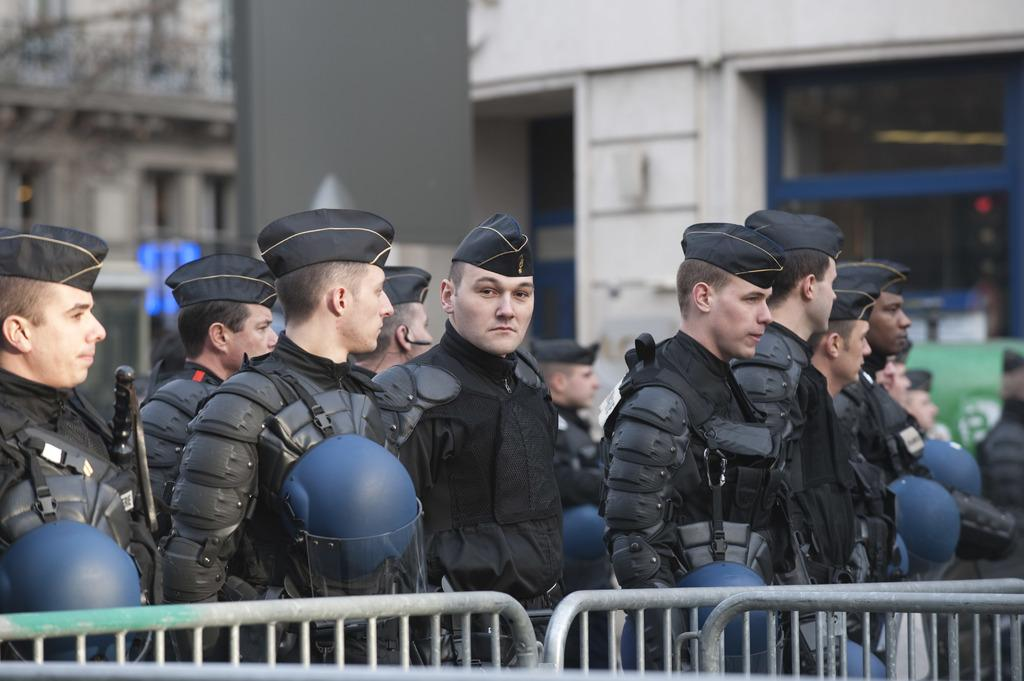What can be seen in the foreground of the image? There are railings in the foreground of the image. What is happening with the group of people in the image? There is a group of people with similar costumes in the image. How is the background of the people depicted in the image? The background of the people is blurred. What type of toothpaste is being used by the people in the image? There is no toothpaste present in the image. What kind of bears can be seen interacting with the people in the image? There are no bears present in the image. 